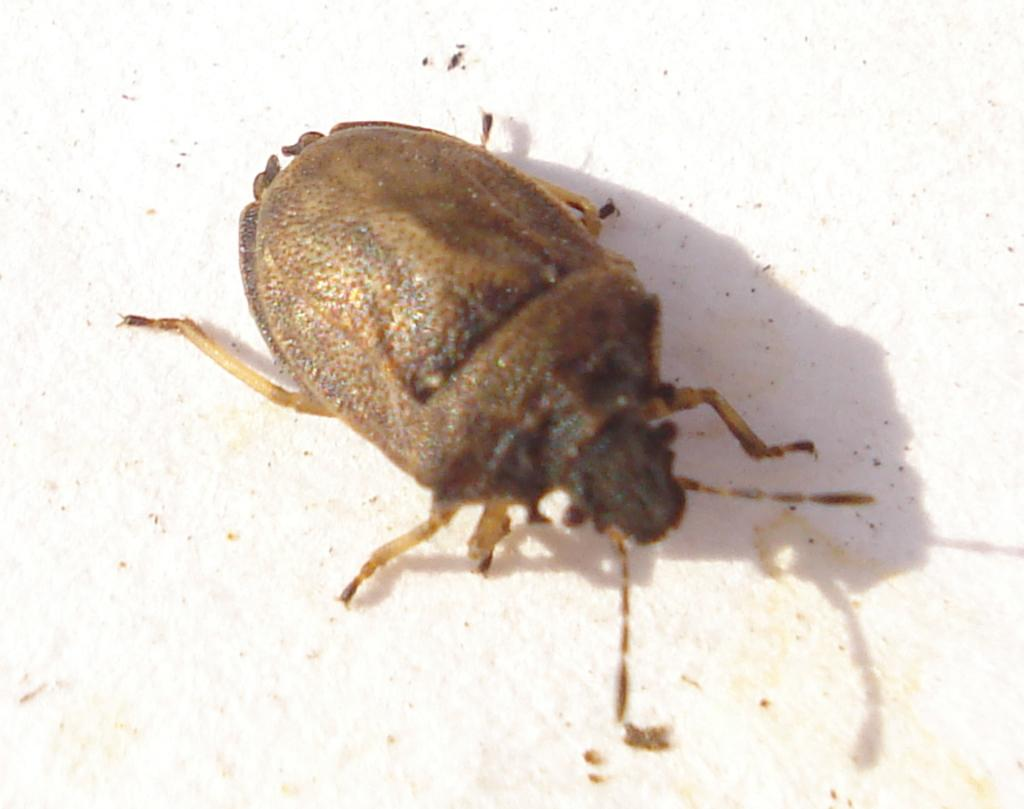What type of creature can be seen in the image? There is an insect in the image. What is the background or surface that the insect is on? The insect is on a white surface. What type of mitten is the insect wearing in the image? There is no mitten present in the image, and insects do not wear clothing. 